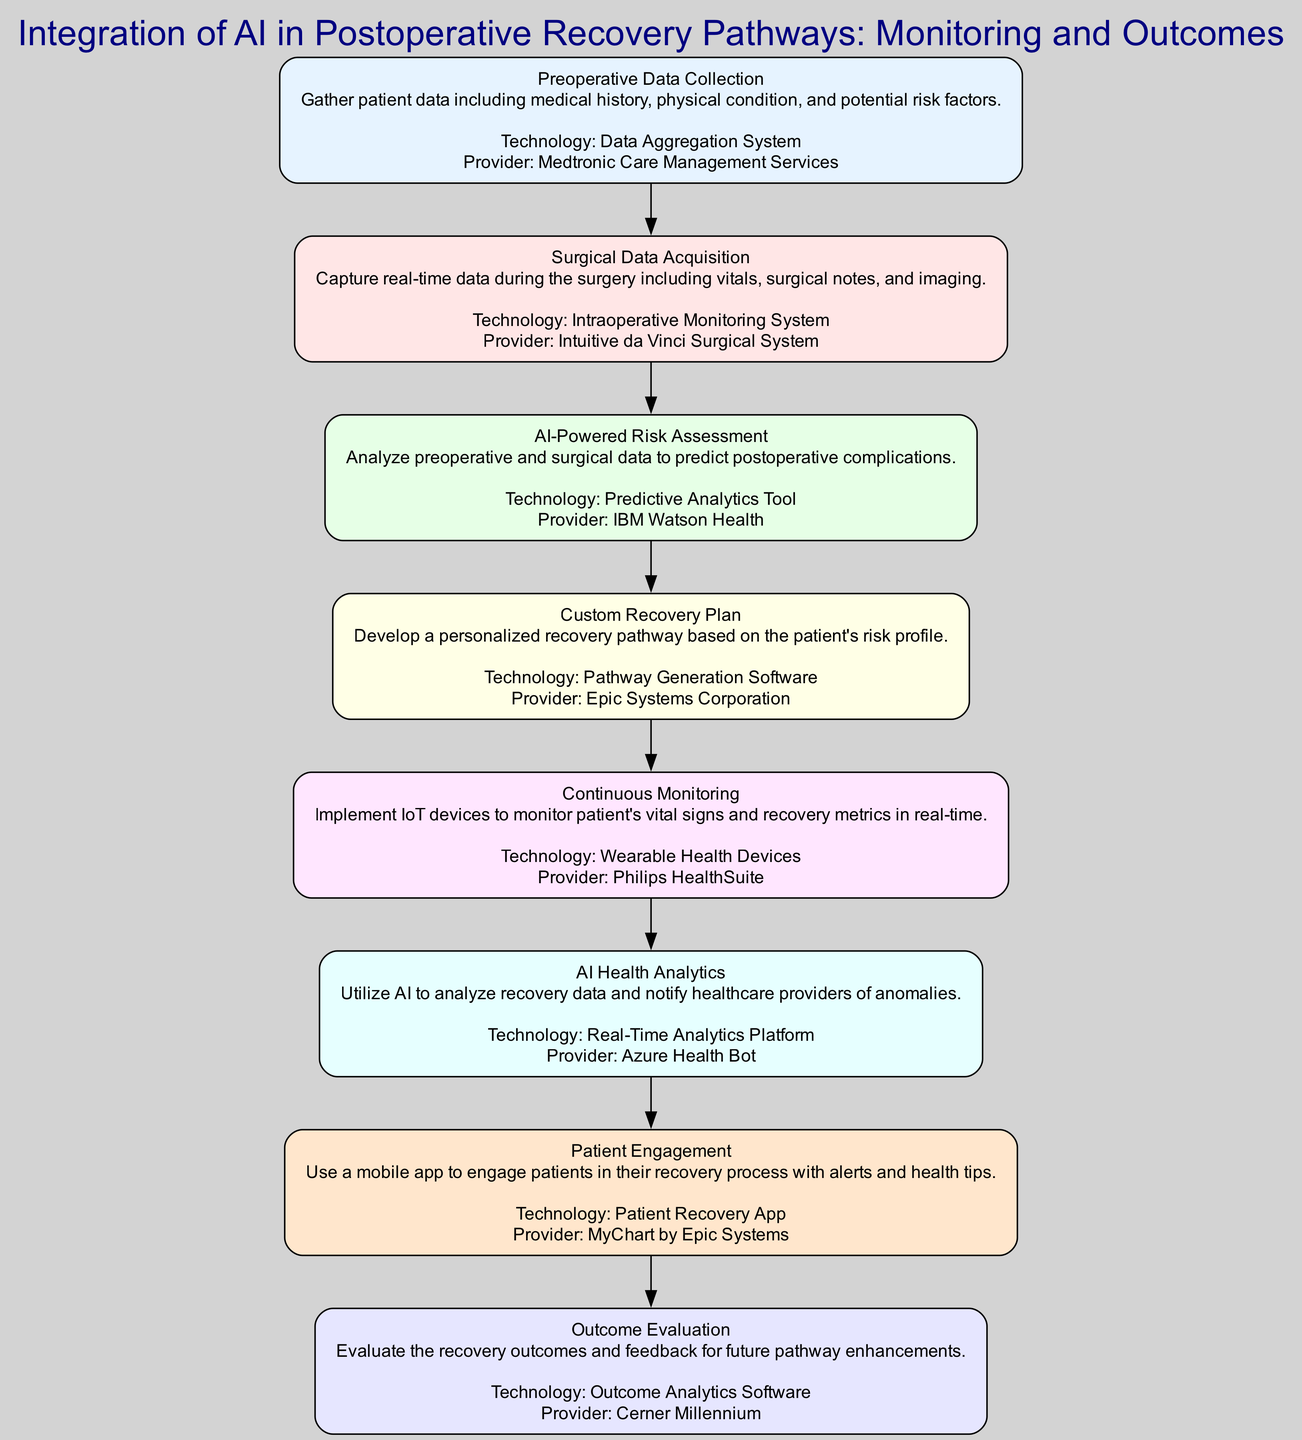What is the title of the clinical pathway? The title is the main label at the top of the diagram, indicating the focus of the pathway, which is the "Integration of AI in Postoperative Recovery Pathways: Monitoring and Outcomes".
Answer: Integration of AI in Postoperative Recovery Pathways: Monitoring and Outcomes How many steps are there in this clinical pathway? By counting the individual steps listed in the diagram, we find that there are a total of 8 distinct steps.
Answer: 8 Which technology is used for continuous monitoring? The continuous monitoring step specifically mentions the technology called "Wearable Health Devices", which enables real-time observation of patient vital signs.
Answer: Wearable Health Devices What is the purpose of the AI-Powered Risk Assessment step? This step’s description indicates that its goal is to analyze data to predict potential postoperative complications for patients.
Answer: Predict postoperative complications Which step comes after Surgical Data Acquisition? The flow of the diagram can be followed from one step to the next, and after "Surgical Data Acquisition", the next step is "AI-Powered Risk Assessment".
Answer: AI-Powered Risk Assessment What technology is used to develop a personalized recovery pathway? The step labeled "Custom Recovery Plan" indicates the use of the "Pathway Generation Software" to create tailored recovery plans for patients.
Answer: Pathway Generation Software How does the Patient Engagement step aid patients? The description details that this step involves a mobile app that provides alerts and health tips to engage patients in their recovery process.
Answer: Alerts and health tips Which organization provides the Predictive Analytics Tool? The specific organization mentioned in the diagram for the Predictive Analytics Tool is "IBM Watson Health".
Answer: IBM Watson Health 